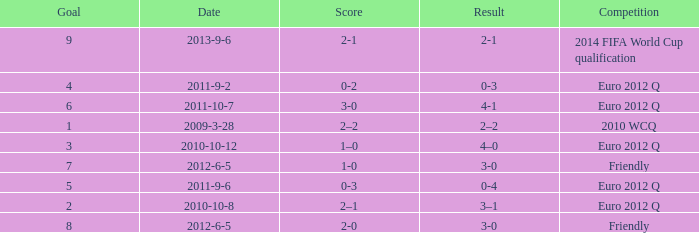What is the result when the score is 0-2? 0-3. 